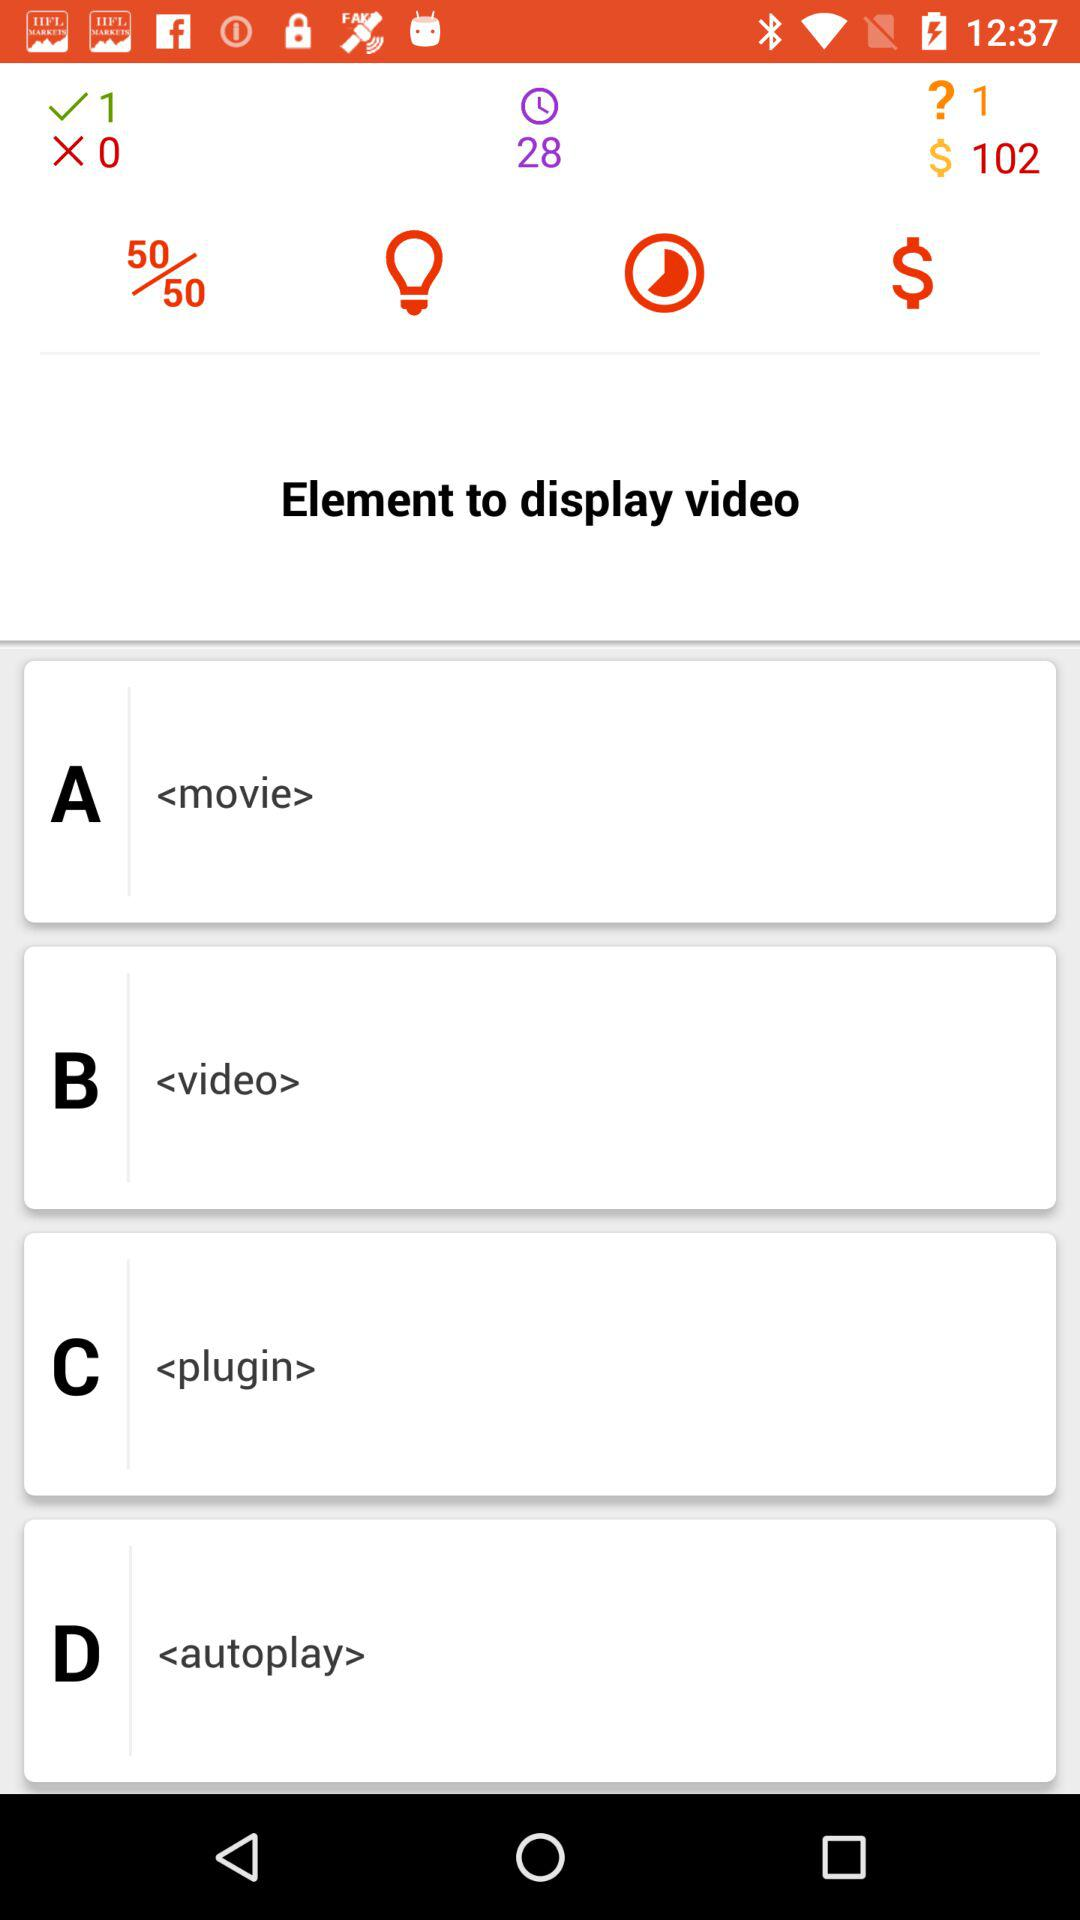What is the total number of answers successfully submitted? The total number of answers successfully submitted is 1. 